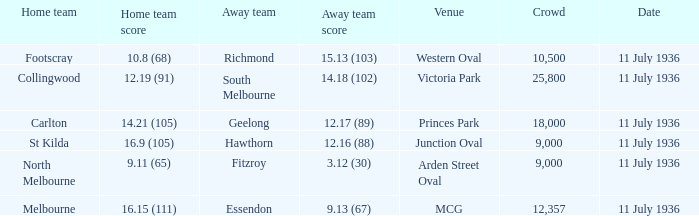When did the game occur with richmond as the away side? 11 July 1936. 